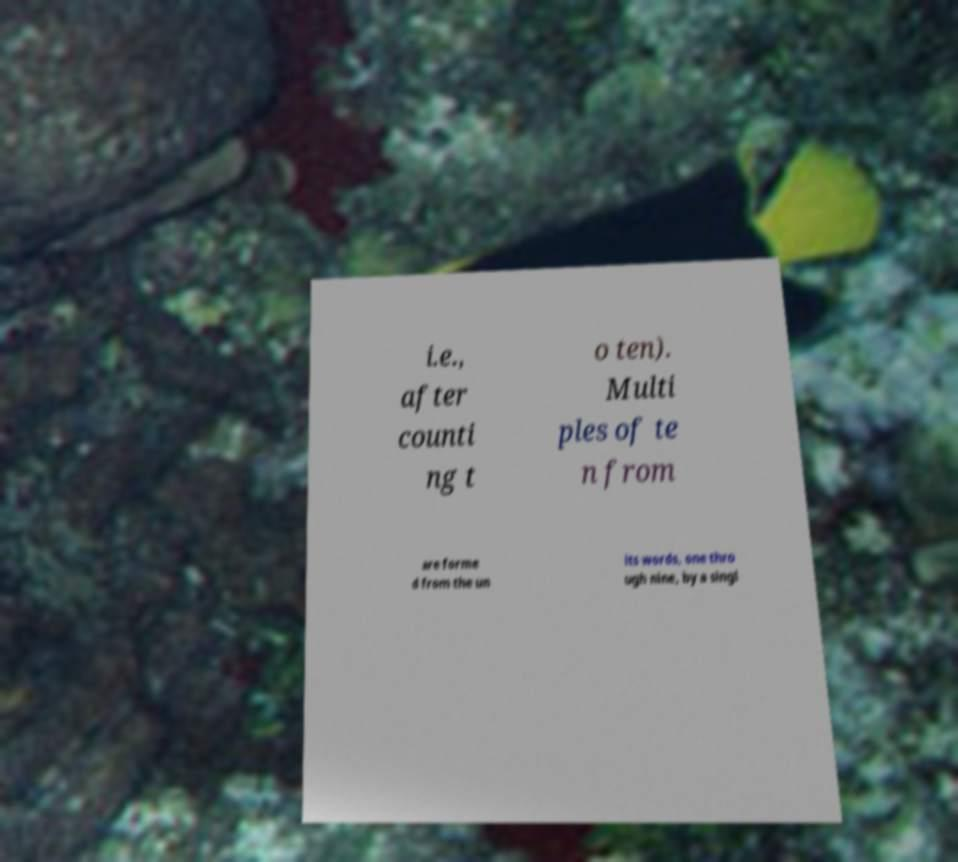Please read and relay the text visible in this image. What does it say? i.e., after counti ng t o ten). Multi ples of te n from are forme d from the un its words, one thro ugh nine, by a singl 